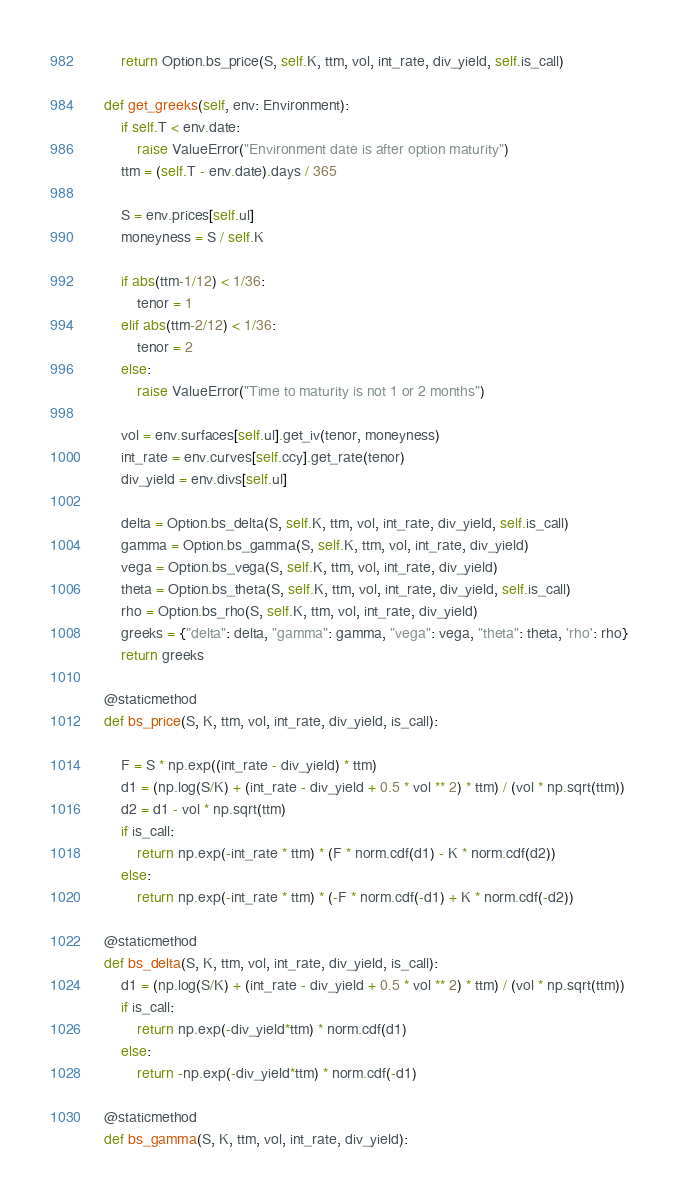Convert code to text. <code><loc_0><loc_0><loc_500><loc_500><_Python_>        return Option.bs_price(S, self.K, ttm, vol, int_rate, div_yield, self.is_call)

    def get_greeks(self, env: Environment):
        if self.T < env.date:
            raise ValueError("Environment date is after option maturity")
        ttm = (self.T - env.date).days / 365

        S = env.prices[self.ul]
        moneyness = S / self.K

        if abs(ttm-1/12) < 1/36:
            tenor = 1
        elif abs(ttm-2/12) < 1/36:
            tenor = 2
        else:
            raise ValueError("Time to maturity is not 1 or 2 months")

        vol = env.surfaces[self.ul].get_iv(tenor, moneyness)
        int_rate = env.curves[self.ccy].get_rate(tenor)
        div_yield = env.divs[self.ul]

        delta = Option.bs_delta(S, self.K, ttm, vol, int_rate, div_yield, self.is_call)
        gamma = Option.bs_gamma(S, self.K, ttm, vol, int_rate, div_yield)
        vega = Option.bs_vega(S, self.K, ttm, vol, int_rate, div_yield)
        theta = Option.bs_theta(S, self.K, ttm, vol, int_rate, div_yield, self.is_call)
        rho = Option.bs_rho(S, self.K, ttm, vol, int_rate, div_yield)
        greeks = {"delta": delta, "gamma": gamma, "vega": vega, "theta": theta, 'rho': rho}
        return greeks

    @staticmethod
    def bs_price(S, K, ttm, vol, int_rate, div_yield, is_call):

        F = S * np.exp((int_rate - div_yield) * ttm)
        d1 = (np.log(S/K) + (int_rate - div_yield + 0.5 * vol ** 2) * ttm) / (vol * np.sqrt(ttm))
        d2 = d1 - vol * np.sqrt(ttm)
        if is_call:
            return np.exp(-int_rate * ttm) * (F * norm.cdf(d1) - K * norm.cdf(d2))
        else:
            return np.exp(-int_rate * ttm) * (-F * norm.cdf(-d1) + K * norm.cdf(-d2))

    @staticmethod
    def bs_delta(S, K, ttm, vol, int_rate, div_yield, is_call):
        d1 = (np.log(S/K) + (int_rate - div_yield + 0.5 * vol ** 2) * ttm) / (vol * np.sqrt(ttm))
        if is_call:
            return np.exp(-div_yield*ttm) * norm.cdf(d1)
        else:
            return -np.exp(-div_yield*ttm) * norm.cdf(-d1)

    @staticmethod
    def bs_gamma(S, K, ttm, vol, int_rate, div_yield):</code> 